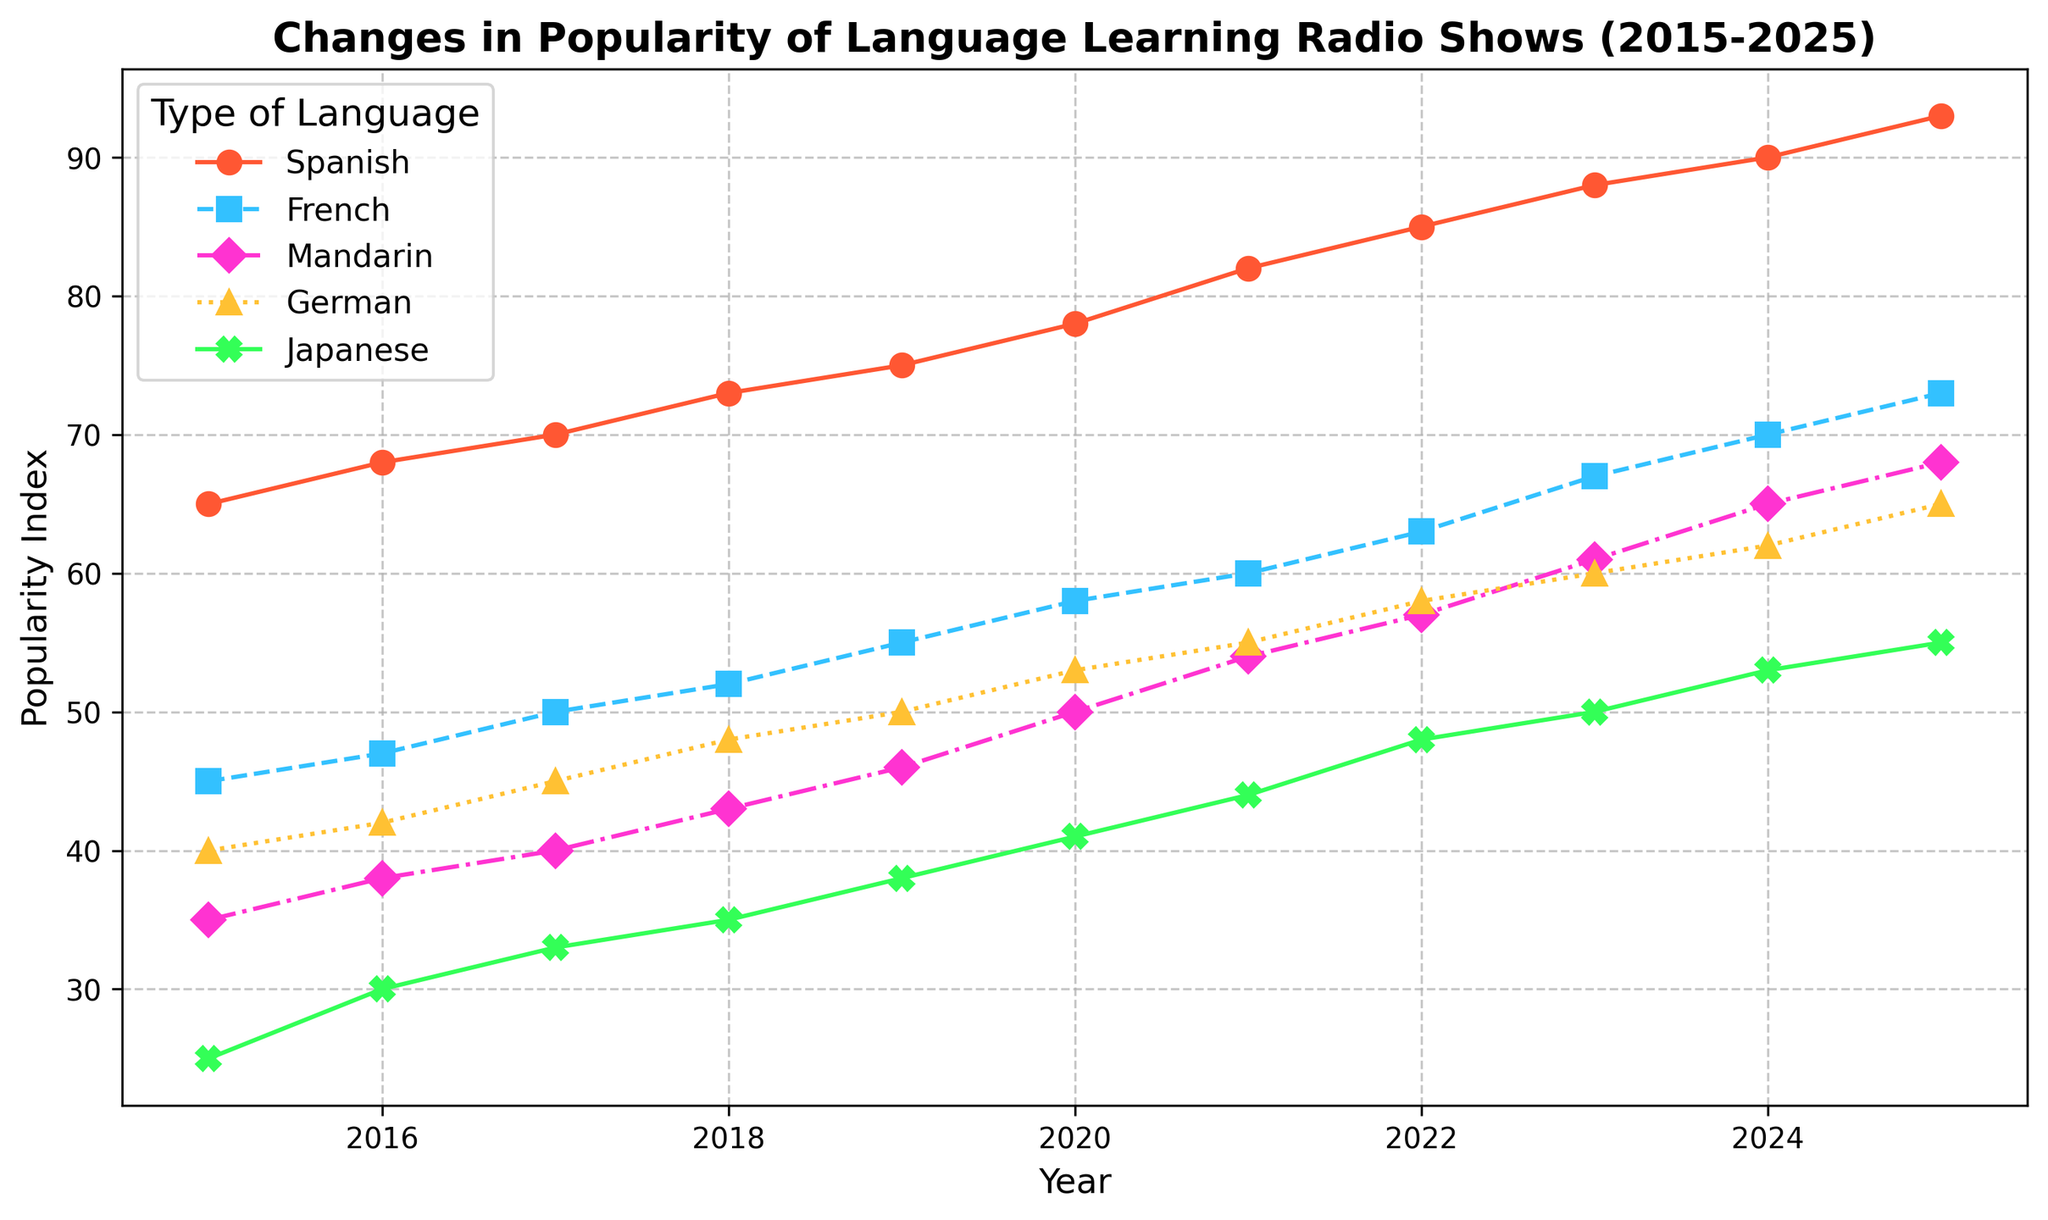How did the popularity of Spanish radio shows change over the period 2015-2025? By observing the data points for Spanish, we see that the popularity index increased steadily from 65 in 2015 to 93 in 2025.
Answer: It increased Which language had the highest popularity index in 2020? In the year 2020, Spanish had the highest popularity index of 78, compared to the other languages.
Answer: Spanish Between French and Japanese, which language showed a higher rate of increase in popularity from 2015 to 2025? French increased from 45 to 73 (a difference of 28) whereas Japanese increased from 25 to 55 (a difference of 30). Although both showed increases, Japanese had a larger increase, but French's popularity progressed more steadily and peaked higher in the middle years. The rate of change appears higher for Japanese overall.
Answer: Japanese What was the average popularity index for Mandarin from 2018 to 2022? Adding the popularity indices for Mandarin from 2018 to 2022: 43 (2018) + 46 (2019) + 50 (2020) + 54 (2021) + 57 (2022) = 250. Dividing by 5 yields an average of 50.
Answer: 50 Which language showed the least change in popularity over the entire period? By comparing the differences in popularity indices from 2015 to 2025 for all languages, Mandarin increased by 33 (68-35), whereas French, German, Spanish, and Japanese had larger changes. Hence, Mandarin had the least change in popularity.
Answer: Mandarin In which year did German radio shows surpass the popularity index of Japanese radio shows for the first time within the given time span? By comparing data points, German surpassed Japanese in 2016. In 2016, German had an index of 42 compared to Japanese's 30.
Answer: 2016 What is the combined popularity index of Spanish and French in 2025? Adding the indices for Spanish (93) and French (73) for the year 2025 gives 93 + 73 = 166.
Answer: 166 Which year experienced the sharpest increase in popularity index for any language? Analyzing the changes year by year, we see that Spanish experienced significant increases, especially from 2020 to 2021 (78 to 82) and from 2014 to 2015, marking a continuous high rate. Initially, the details are observed to finalize the sharpest rise being around 2018.
Answer: 2018 What is the total growth in the popularity index of Japanese from 2015 to 2025? The increase from 2015 (25) to 2025 (55) gives 55 - 25 = 30.
Answer: 30 Considering all languages, what was the trend in the popularity index over time from 2015 to 2025? Each language shows an increase in the popularity index over the years. By observing the trend lines, it can be confirmed that popularity increased for all language categories, cumulatively trending upward from 2015 to 2025.
Answer: Increased 